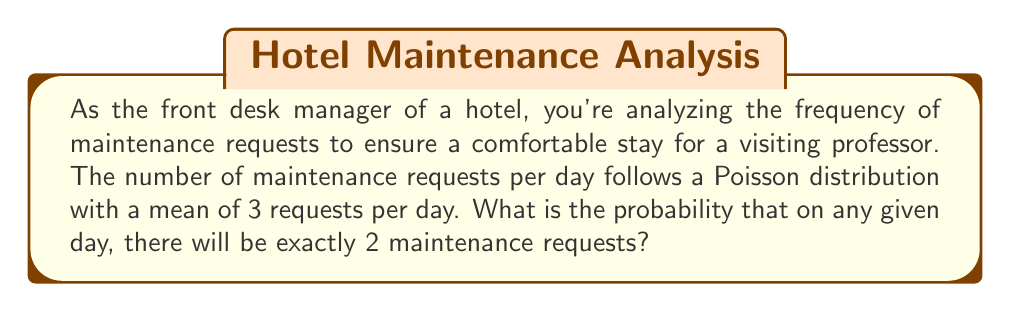Show me your answer to this math problem. Let's approach this step-by-step:

1) The Poisson distribution is used for discrete random variables that represent the number of events occurring in a fixed interval of time or space.

2) The probability mass function for a Poisson distribution is:

   $$P(X = k) = \frac{e^{-\lambda}\lambda^k}{k!}$$

   Where:
   - $\lambda$ is the average number of events per interval
   - $k$ is the number of events we're interested in
   - $e$ is Euler's number (approximately 2.71828)

3) In this case:
   - $\lambda = 3$ (mean of 3 requests per day)
   - $k = 2$ (we're interested in exactly 2 requests)

4) Let's substitute these values into the formula:

   $$P(X = 2) = \frac{e^{-3}3^2}{2!}$$

5) Simplify:
   - $e^{-3} \approx 0.0497871$
   - $3^2 = 9$
   - $2! = 2 \times 1 = 2$

   $$P(X = 2) = \frac{0.0497871 \times 9}{2} \approx 0.2240$$

6) Therefore, the probability of exactly 2 maintenance requests in a day is approximately 0.2240 or 22.40%.
Answer: 0.2240 